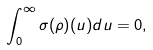<formula> <loc_0><loc_0><loc_500><loc_500>\int _ { 0 } ^ { \infty } \sigma ( \rho ) ( u ) d u = 0 ,</formula> 